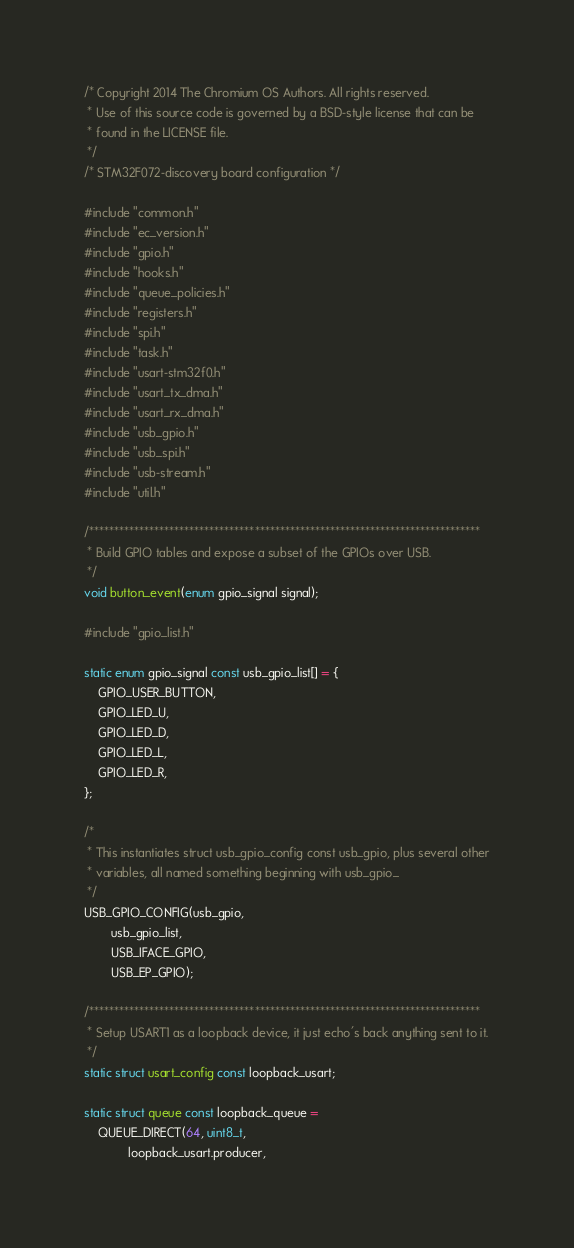<code> <loc_0><loc_0><loc_500><loc_500><_C_>/* Copyright 2014 The Chromium OS Authors. All rights reserved.
 * Use of this source code is governed by a BSD-style license that can be
 * found in the LICENSE file.
 */
/* STM32F072-discovery board configuration */

#include "common.h"
#include "ec_version.h"
#include "gpio.h"
#include "hooks.h"
#include "queue_policies.h"
#include "registers.h"
#include "spi.h"
#include "task.h"
#include "usart-stm32f0.h"
#include "usart_tx_dma.h"
#include "usart_rx_dma.h"
#include "usb_gpio.h"
#include "usb_spi.h"
#include "usb-stream.h"
#include "util.h"

/******************************************************************************
 * Build GPIO tables and expose a subset of the GPIOs over USB.
 */
void button_event(enum gpio_signal signal);

#include "gpio_list.h"

static enum gpio_signal const usb_gpio_list[] = {
	GPIO_USER_BUTTON,
	GPIO_LED_U,
	GPIO_LED_D,
	GPIO_LED_L,
	GPIO_LED_R,
};

/*
 * This instantiates struct usb_gpio_config const usb_gpio, plus several other
 * variables, all named something beginning with usb_gpio_
 */
USB_GPIO_CONFIG(usb_gpio,
		usb_gpio_list,
		USB_IFACE_GPIO,
		USB_EP_GPIO);

/******************************************************************************
 * Setup USART1 as a loopback device, it just echo's back anything sent to it.
 */
static struct usart_config const loopback_usart;

static struct queue const loopback_queue =
	QUEUE_DIRECT(64, uint8_t,
		     loopback_usart.producer,</code> 